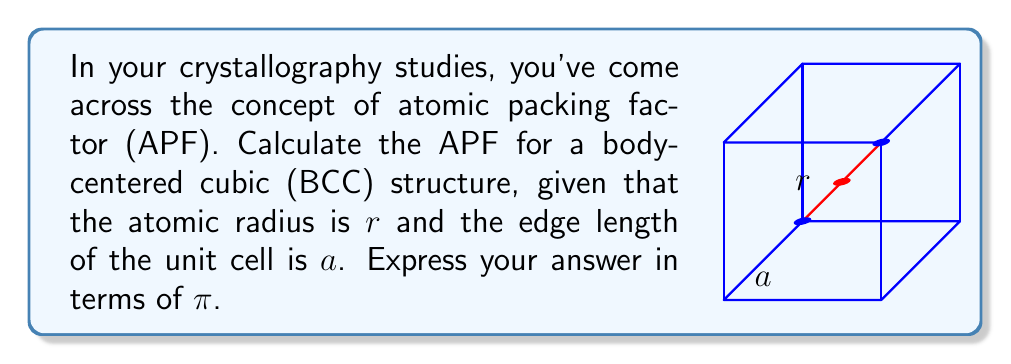Can you solve this math problem? Let's approach this step-by-step:

1) The atomic packing factor (APF) is defined as:

   $$ APF = \frac{\text{Volume of atoms in a unit cell}}{\text{Total volume of the unit cell}} $$

2) For a BCC structure, there are 2 atoms per unit cell: one at the center and 1/8 of an atom at each of the 8 corners.

3) The volume of a sphere (atom) is $V_{atom} = \frac{4}{3}\pi r^3$

4) The total volume of atoms in the unit cell is:
   $$ V_{atoms} = 2 \cdot \frac{4}{3}\pi r^3 = \frac{8}{3}\pi r^3 $$

5) The volume of the cubic unit cell is:
   $$ V_{cell} = a^3 $$

6) In a BCC structure, the body diagonal passes through two atomic radii:
   $$ a\sqrt{3} = 4r $$
   $$ a = \frac{4r}{\sqrt{3}} $$

7) Substituting this into the unit cell volume:
   $$ V_{cell} = \left(\frac{4r}{\sqrt{3}}\right)^3 = \frac{64r^3}{3\sqrt{3}} $$

8) Now we can calculate the APF:
   $$ APF = \frac{V_{atoms}}{V_{cell}} = \frac{\frac{8}{3}\pi r^3}{\frac{64r^3}{3\sqrt{3}}} = \frac{8\pi r^3 \cdot 3\sqrt{3}}{3 \cdot 64r^3} = \frac{\pi\sqrt{3}}{8} $$
Answer: $\frac{\pi\sqrt{3}}{8}$ 